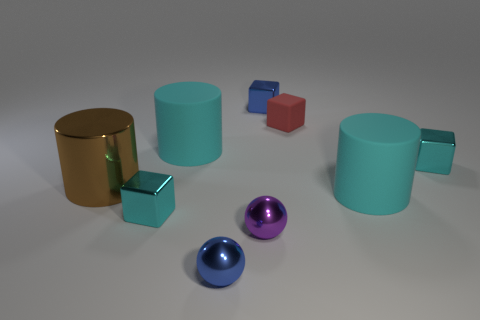The purple sphere that is made of the same material as the large brown thing is what size?
Your answer should be compact. Small. What number of big objects are the same color as the rubber cube?
Your answer should be very brief. 0. Are there any tiny blue balls on the left side of the purple metallic sphere?
Keep it short and to the point. Yes. There is a tiny red thing; is its shape the same as the small cyan thing behind the large brown metallic cylinder?
Offer a terse response. Yes. How many objects are tiny metallic things behind the small purple metallic ball or large gray shiny things?
Keep it short and to the point. 3. What number of tiny metal objects are both behind the purple metallic object and on the right side of the blue metallic ball?
Provide a short and direct response. 2. What number of things are either cyan things in front of the big brown metal cylinder or large cyan cylinders that are to the left of the blue shiny sphere?
Give a very brief answer. 3. What number of other objects are there of the same shape as the red matte object?
Your response must be concise. 3. What number of other objects are the same size as the brown shiny object?
Offer a very short reply. 2. Is the material of the tiny blue cube the same as the blue sphere?
Your answer should be compact. Yes. 